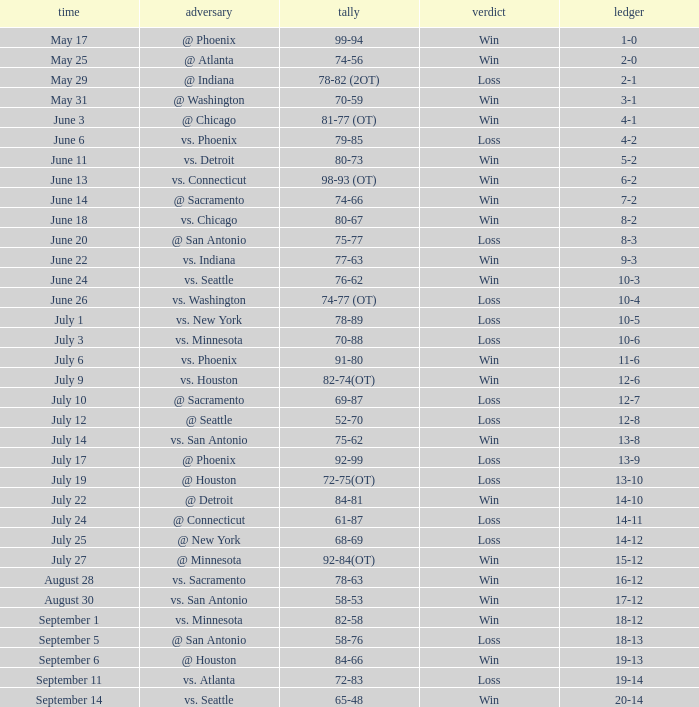What is the Score of the game @ San Antonio on June 20? 75-77. 